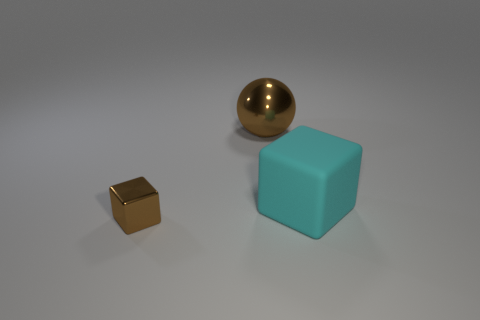Is there any other thing that is made of the same material as the large cube?
Keep it short and to the point. No. Is the size of the thing that is behind the cyan rubber thing the same as the big rubber object?
Provide a short and direct response. Yes. Is the metal sphere the same color as the small metal thing?
Make the answer very short. Yes. What number of big matte things are there?
Your response must be concise. 1. How many balls are tiny cyan things or big shiny things?
Provide a succinct answer. 1. What number of brown objects are to the left of the metallic object behind the small brown metal object?
Your answer should be compact. 1. Does the big brown object have the same material as the big cyan block?
Offer a terse response. No. The thing that is the same color as the small cube is what size?
Offer a terse response. Large. Is there a cyan cylinder that has the same material as the cyan thing?
Ensure brevity in your answer.  No. There is a object that is in front of the large thing that is right of the brown shiny thing behind the cyan cube; what color is it?
Keep it short and to the point. Brown. 